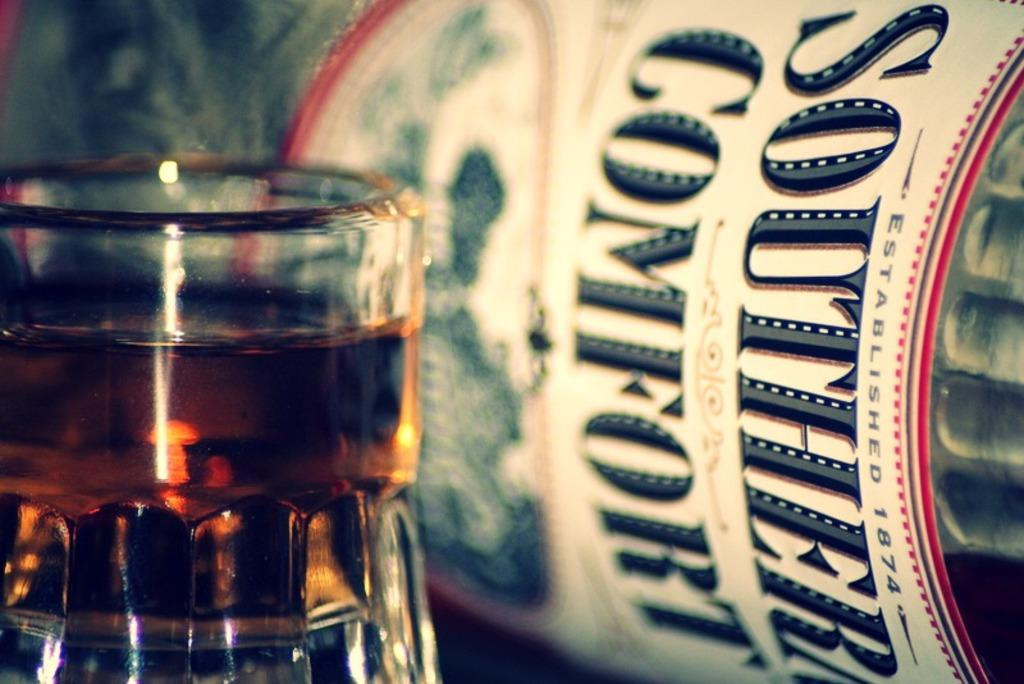<image>
Present a compact description of the photo's key features. Bottle of southern comfort lays on it side next to a full glass. 